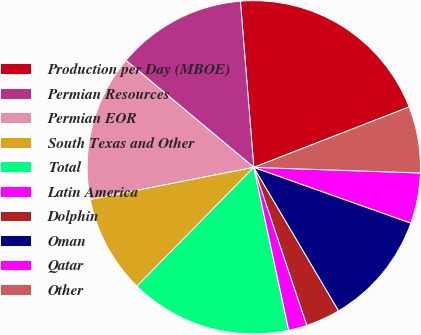Convert chart. <chart><loc_0><loc_0><loc_500><loc_500><pie_chart><fcel>Production per Day (MBOE)<fcel>Permian Resources<fcel>Permian EOR<fcel>South Texas and Other<fcel>Total<fcel>Latin America<fcel>Dolphin<fcel>Oman<fcel>Qatar<fcel>Other<nl><fcel>20.38%<fcel>12.63%<fcel>14.18%<fcel>9.54%<fcel>15.73%<fcel>1.79%<fcel>3.34%<fcel>11.08%<fcel>4.89%<fcel>6.44%<nl></chart> 